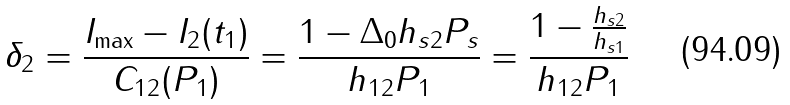Convert formula to latex. <formula><loc_0><loc_0><loc_500><loc_500>\delta _ { 2 } = \frac { I _ { \max } - I _ { 2 } ( t _ { 1 } ) } { C _ { 1 2 } ( P _ { 1 } ) } = \frac { 1 - \Delta _ { 0 } { h _ { s 2 } P _ { s } } } { { h _ { 1 2 } P _ { 1 } } } = \frac { 1 - { \frac { h _ { s 2 } } { h _ { s 1 } } } } { { h _ { 1 2 } P _ { 1 } } }</formula> 